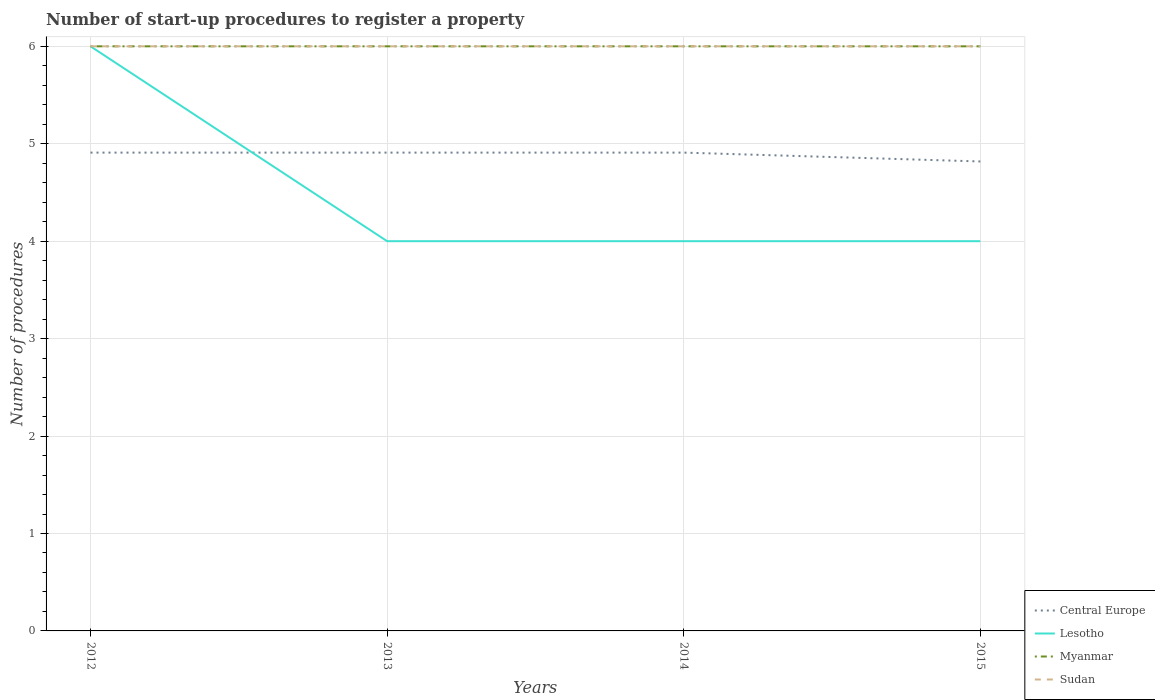Is the number of lines equal to the number of legend labels?
Provide a succinct answer. Yes. Across all years, what is the maximum number of procedures required to register a property in Lesotho?
Make the answer very short. 4. In which year was the number of procedures required to register a property in Sudan maximum?
Your answer should be compact. 2012. What is the difference between the highest and the second highest number of procedures required to register a property in Central Europe?
Provide a short and direct response. 0.09. What is the difference between the highest and the lowest number of procedures required to register a property in Sudan?
Make the answer very short. 0. Is the number of procedures required to register a property in Myanmar strictly greater than the number of procedures required to register a property in Sudan over the years?
Give a very brief answer. No. How many lines are there?
Your answer should be compact. 4. Are the values on the major ticks of Y-axis written in scientific E-notation?
Provide a short and direct response. No. Does the graph contain any zero values?
Ensure brevity in your answer.  No. How are the legend labels stacked?
Give a very brief answer. Vertical. What is the title of the graph?
Ensure brevity in your answer.  Number of start-up procedures to register a property. Does "Portugal" appear as one of the legend labels in the graph?
Make the answer very short. No. What is the label or title of the X-axis?
Your answer should be compact. Years. What is the label or title of the Y-axis?
Your response must be concise. Number of procedures. What is the Number of procedures of Central Europe in 2012?
Offer a very short reply. 4.91. What is the Number of procedures of Lesotho in 2012?
Provide a short and direct response. 6. What is the Number of procedures of Myanmar in 2012?
Ensure brevity in your answer.  6. What is the Number of procedures of Sudan in 2012?
Your response must be concise. 6. What is the Number of procedures of Central Europe in 2013?
Ensure brevity in your answer.  4.91. What is the Number of procedures in Lesotho in 2013?
Give a very brief answer. 4. What is the Number of procedures in Sudan in 2013?
Offer a terse response. 6. What is the Number of procedures of Central Europe in 2014?
Give a very brief answer. 4.91. What is the Number of procedures in Sudan in 2014?
Your answer should be very brief. 6. What is the Number of procedures in Central Europe in 2015?
Ensure brevity in your answer.  4.82. What is the Number of procedures in Lesotho in 2015?
Offer a very short reply. 4. Across all years, what is the maximum Number of procedures of Central Europe?
Keep it short and to the point. 4.91. Across all years, what is the minimum Number of procedures of Central Europe?
Give a very brief answer. 4.82. Across all years, what is the minimum Number of procedures of Lesotho?
Provide a succinct answer. 4. Across all years, what is the minimum Number of procedures in Myanmar?
Make the answer very short. 6. Across all years, what is the minimum Number of procedures of Sudan?
Provide a succinct answer. 6. What is the total Number of procedures in Central Europe in the graph?
Provide a succinct answer. 19.55. What is the total Number of procedures of Myanmar in the graph?
Your response must be concise. 24. What is the total Number of procedures in Sudan in the graph?
Ensure brevity in your answer.  24. What is the difference between the Number of procedures of Lesotho in 2012 and that in 2013?
Offer a terse response. 2. What is the difference between the Number of procedures of Myanmar in 2012 and that in 2013?
Offer a terse response. 0. What is the difference between the Number of procedures of Sudan in 2012 and that in 2013?
Offer a very short reply. 0. What is the difference between the Number of procedures in Sudan in 2012 and that in 2014?
Your answer should be compact. 0. What is the difference between the Number of procedures of Central Europe in 2012 and that in 2015?
Offer a terse response. 0.09. What is the difference between the Number of procedures of Lesotho in 2012 and that in 2015?
Offer a very short reply. 2. What is the difference between the Number of procedures in Sudan in 2012 and that in 2015?
Your answer should be very brief. 0. What is the difference between the Number of procedures in Lesotho in 2013 and that in 2014?
Keep it short and to the point. 0. What is the difference between the Number of procedures in Sudan in 2013 and that in 2014?
Your response must be concise. 0. What is the difference between the Number of procedures in Central Europe in 2013 and that in 2015?
Your response must be concise. 0.09. What is the difference between the Number of procedures in Lesotho in 2013 and that in 2015?
Your response must be concise. 0. What is the difference between the Number of procedures in Myanmar in 2013 and that in 2015?
Offer a terse response. 0. What is the difference between the Number of procedures in Central Europe in 2014 and that in 2015?
Your response must be concise. 0.09. What is the difference between the Number of procedures of Myanmar in 2014 and that in 2015?
Give a very brief answer. 0. What is the difference between the Number of procedures in Central Europe in 2012 and the Number of procedures in Myanmar in 2013?
Provide a succinct answer. -1.09. What is the difference between the Number of procedures in Central Europe in 2012 and the Number of procedures in Sudan in 2013?
Your answer should be very brief. -1.09. What is the difference between the Number of procedures of Central Europe in 2012 and the Number of procedures of Myanmar in 2014?
Your response must be concise. -1.09. What is the difference between the Number of procedures of Central Europe in 2012 and the Number of procedures of Sudan in 2014?
Offer a terse response. -1.09. What is the difference between the Number of procedures in Lesotho in 2012 and the Number of procedures in Myanmar in 2014?
Give a very brief answer. 0. What is the difference between the Number of procedures of Myanmar in 2012 and the Number of procedures of Sudan in 2014?
Your answer should be very brief. 0. What is the difference between the Number of procedures in Central Europe in 2012 and the Number of procedures in Lesotho in 2015?
Provide a succinct answer. 0.91. What is the difference between the Number of procedures in Central Europe in 2012 and the Number of procedures in Myanmar in 2015?
Keep it short and to the point. -1.09. What is the difference between the Number of procedures of Central Europe in 2012 and the Number of procedures of Sudan in 2015?
Your response must be concise. -1.09. What is the difference between the Number of procedures of Lesotho in 2012 and the Number of procedures of Myanmar in 2015?
Offer a very short reply. 0. What is the difference between the Number of procedures of Lesotho in 2012 and the Number of procedures of Sudan in 2015?
Offer a terse response. 0. What is the difference between the Number of procedures of Central Europe in 2013 and the Number of procedures of Lesotho in 2014?
Ensure brevity in your answer.  0.91. What is the difference between the Number of procedures in Central Europe in 2013 and the Number of procedures in Myanmar in 2014?
Make the answer very short. -1.09. What is the difference between the Number of procedures in Central Europe in 2013 and the Number of procedures in Sudan in 2014?
Your response must be concise. -1.09. What is the difference between the Number of procedures of Central Europe in 2013 and the Number of procedures of Myanmar in 2015?
Offer a very short reply. -1.09. What is the difference between the Number of procedures in Central Europe in 2013 and the Number of procedures in Sudan in 2015?
Keep it short and to the point. -1.09. What is the difference between the Number of procedures in Lesotho in 2013 and the Number of procedures in Myanmar in 2015?
Provide a succinct answer. -2. What is the difference between the Number of procedures in Lesotho in 2013 and the Number of procedures in Sudan in 2015?
Ensure brevity in your answer.  -2. What is the difference between the Number of procedures of Central Europe in 2014 and the Number of procedures of Myanmar in 2015?
Provide a succinct answer. -1.09. What is the difference between the Number of procedures of Central Europe in 2014 and the Number of procedures of Sudan in 2015?
Your response must be concise. -1.09. What is the difference between the Number of procedures of Lesotho in 2014 and the Number of procedures of Myanmar in 2015?
Provide a short and direct response. -2. What is the difference between the Number of procedures in Myanmar in 2014 and the Number of procedures in Sudan in 2015?
Your answer should be very brief. 0. What is the average Number of procedures of Central Europe per year?
Make the answer very short. 4.89. What is the average Number of procedures in Myanmar per year?
Ensure brevity in your answer.  6. What is the average Number of procedures of Sudan per year?
Provide a short and direct response. 6. In the year 2012, what is the difference between the Number of procedures in Central Europe and Number of procedures in Lesotho?
Provide a short and direct response. -1.09. In the year 2012, what is the difference between the Number of procedures in Central Europe and Number of procedures in Myanmar?
Provide a short and direct response. -1.09. In the year 2012, what is the difference between the Number of procedures of Central Europe and Number of procedures of Sudan?
Your answer should be compact. -1.09. In the year 2012, what is the difference between the Number of procedures of Lesotho and Number of procedures of Myanmar?
Give a very brief answer. 0. In the year 2012, what is the difference between the Number of procedures of Myanmar and Number of procedures of Sudan?
Offer a terse response. 0. In the year 2013, what is the difference between the Number of procedures of Central Europe and Number of procedures of Lesotho?
Your answer should be very brief. 0.91. In the year 2013, what is the difference between the Number of procedures in Central Europe and Number of procedures in Myanmar?
Give a very brief answer. -1.09. In the year 2013, what is the difference between the Number of procedures of Central Europe and Number of procedures of Sudan?
Offer a terse response. -1.09. In the year 2013, what is the difference between the Number of procedures of Lesotho and Number of procedures of Sudan?
Ensure brevity in your answer.  -2. In the year 2013, what is the difference between the Number of procedures of Myanmar and Number of procedures of Sudan?
Your answer should be compact. 0. In the year 2014, what is the difference between the Number of procedures in Central Europe and Number of procedures in Myanmar?
Offer a terse response. -1.09. In the year 2014, what is the difference between the Number of procedures in Central Europe and Number of procedures in Sudan?
Keep it short and to the point. -1.09. In the year 2014, what is the difference between the Number of procedures in Lesotho and Number of procedures in Myanmar?
Ensure brevity in your answer.  -2. In the year 2014, what is the difference between the Number of procedures in Myanmar and Number of procedures in Sudan?
Your answer should be very brief. 0. In the year 2015, what is the difference between the Number of procedures in Central Europe and Number of procedures in Lesotho?
Keep it short and to the point. 0.82. In the year 2015, what is the difference between the Number of procedures of Central Europe and Number of procedures of Myanmar?
Your response must be concise. -1.18. In the year 2015, what is the difference between the Number of procedures in Central Europe and Number of procedures in Sudan?
Provide a short and direct response. -1.18. In the year 2015, what is the difference between the Number of procedures in Lesotho and Number of procedures in Myanmar?
Provide a short and direct response. -2. In the year 2015, what is the difference between the Number of procedures in Lesotho and Number of procedures in Sudan?
Provide a short and direct response. -2. In the year 2015, what is the difference between the Number of procedures of Myanmar and Number of procedures of Sudan?
Keep it short and to the point. 0. What is the ratio of the Number of procedures of Central Europe in 2012 to that in 2013?
Keep it short and to the point. 1. What is the ratio of the Number of procedures of Myanmar in 2012 to that in 2014?
Offer a very short reply. 1. What is the ratio of the Number of procedures of Sudan in 2012 to that in 2014?
Make the answer very short. 1. What is the ratio of the Number of procedures of Central Europe in 2012 to that in 2015?
Your answer should be compact. 1.02. What is the ratio of the Number of procedures in Lesotho in 2012 to that in 2015?
Your answer should be compact. 1.5. What is the ratio of the Number of procedures of Myanmar in 2012 to that in 2015?
Provide a succinct answer. 1. What is the ratio of the Number of procedures of Lesotho in 2013 to that in 2014?
Provide a succinct answer. 1. What is the ratio of the Number of procedures in Myanmar in 2013 to that in 2014?
Ensure brevity in your answer.  1. What is the ratio of the Number of procedures in Central Europe in 2013 to that in 2015?
Your response must be concise. 1.02. What is the ratio of the Number of procedures in Lesotho in 2013 to that in 2015?
Keep it short and to the point. 1. What is the ratio of the Number of procedures of Myanmar in 2013 to that in 2015?
Keep it short and to the point. 1. What is the ratio of the Number of procedures in Central Europe in 2014 to that in 2015?
Make the answer very short. 1.02. What is the ratio of the Number of procedures of Sudan in 2014 to that in 2015?
Your response must be concise. 1. What is the difference between the highest and the second highest Number of procedures in Lesotho?
Your response must be concise. 2. What is the difference between the highest and the lowest Number of procedures of Central Europe?
Your response must be concise. 0.09. What is the difference between the highest and the lowest Number of procedures in Lesotho?
Make the answer very short. 2. 